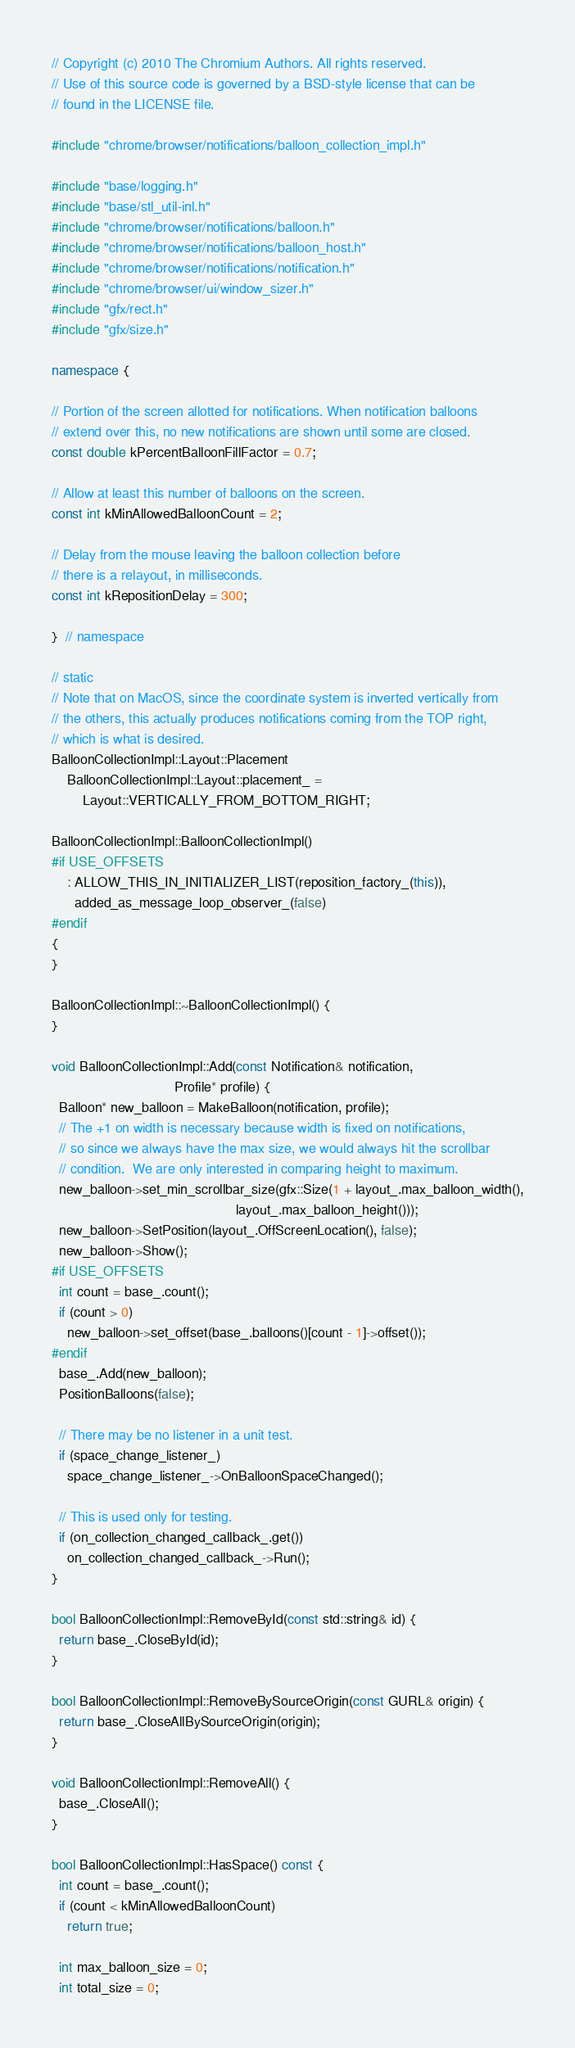Convert code to text. <code><loc_0><loc_0><loc_500><loc_500><_C++_>// Copyright (c) 2010 The Chromium Authors. All rights reserved.
// Use of this source code is governed by a BSD-style license that can be
// found in the LICENSE file.

#include "chrome/browser/notifications/balloon_collection_impl.h"

#include "base/logging.h"
#include "base/stl_util-inl.h"
#include "chrome/browser/notifications/balloon.h"
#include "chrome/browser/notifications/balloon_host.h"
#include "chrome/browser/notifications/notification.h"
#include "chrome/browser/ui/window_sizer.h"
#include "gfx/rect.h"
#include "gfx/size.h"

namespace {

// Portion of the screen allotted for notifications. When notification balloons
// extend over this, no new notifications are shown until some are closed.
const double kPercentBalloonFillFactor = 0.7;

// Allow at least this number of balloons on the screen.
const int kMinAllowedBalloonCount = 2;

// Delay from the mouse leaving the balloon collection before
// there is a relayout, in milliseconds.
const int kRepositionDelay = 300;

}  // namespace

// static
// Note that on MacOS, since the coordinate system is inverted vertically from
// the others, this actually produces notifications coming from the TOP right,
// which is what is desired.
BalloonCollectionImpl::Layout::Placement
    BalloonCollectionImpl::Layout::placement_ =
        Layout::VERTICALLY_FROM_BOTTOM_RIGHT;

BalloonCollectionImpl::BalloonCollectionImpl()
#if USE_OFFSETS
    : ALLOW_THIS_IN_INITIALIZER_LIST(reposition_factory_(this)),
      added_as_message_loop_observer_(false)
#endif
{
}

BalloonCollectionImpl::~BalloonCollectionImpl() {
}

void BalloonCollectionImpl::Add(const Notification& notification,
                                Profile* profile) {
  Balloon* new_balloon = MakeBalloon(notification, profile);
  // The +1 on width is necessary because width is fixed on notifications,
  // so since we always have the max size, we would always hit the scrollbar
  // condition.  We are only interested in comparing height to maximum.
  new_balloon->set_min_scrollbar_size(gfx::Size(1 + layout_.max_balloon_width(),
                                                layout_.max_balloon_height()));
  new_balloon->SetPosition(layout_.OffScreenLocation(), false);
  new_balloon->Show();
#if USE_OFFSETS
  int count = base_.count();
  if (count > 0)
    new_balloon->set_offset(base_.balloons()[count - 1]->offset());
#endif
  base_.Add(new_balloon);
  PositionBalloons(false);

  // There may be no listener in a unit test.
  if (space_change_listener_)
    space_change_listener_->OnBalloonSpaceChanged();

  // This is used only for testing.
  if (on_collection_changed_callback_.get())
    on_collection_changed_callback_->Run();
}

bool BalloonCollectionImpl::RemoveById(const std::string& id) {
  return base_.CloseById(id);
}

bool BalloonCollectionImpl::RemoveBySourceOrigin(const GURL& origin) {
  return base_.CloseAllBySourceOrigin(origin);
}

void BalloonCollectionImpl::RemoveAll() {
  base_.CloseAll();
}

bool BalloonCollectionImpl::HasSpace() const {
  int count = base_.count();
  if (count < kMinAllowedBalloonCount)
    return true;

  int max_balloon_size = 0;
  int total_size = 0;</code> 